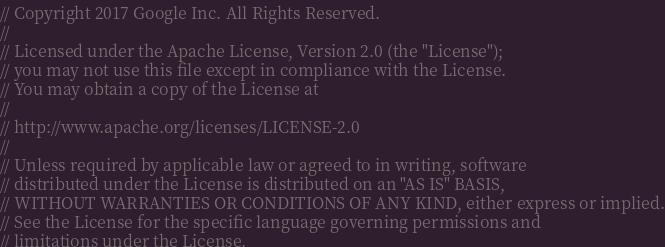Convert code to text. <code><loc_0><loc_0><loc_500><loc_500><_Java_>// Copyright 2017 Google Inc. All Rights Reserved.
//
// Licensed under the Apache License, Version 2.0 (the "License");
// you may not use this file except in compliance with the License.
// You may obtain a copy of the License at
//
// http://www.apache.org/licenses/LICENSE-2.0
//
// Unless required by applicable law or agreed to in writing, software
// distributed under the License is distributed on an "AS IS" BASIS,
// WITHOUT WARRANTIES OR CONDITIONS OF ANY KIND, either express or implied.
// See the License for the specific language governing permissions and
// limitations under the License.

</code> 